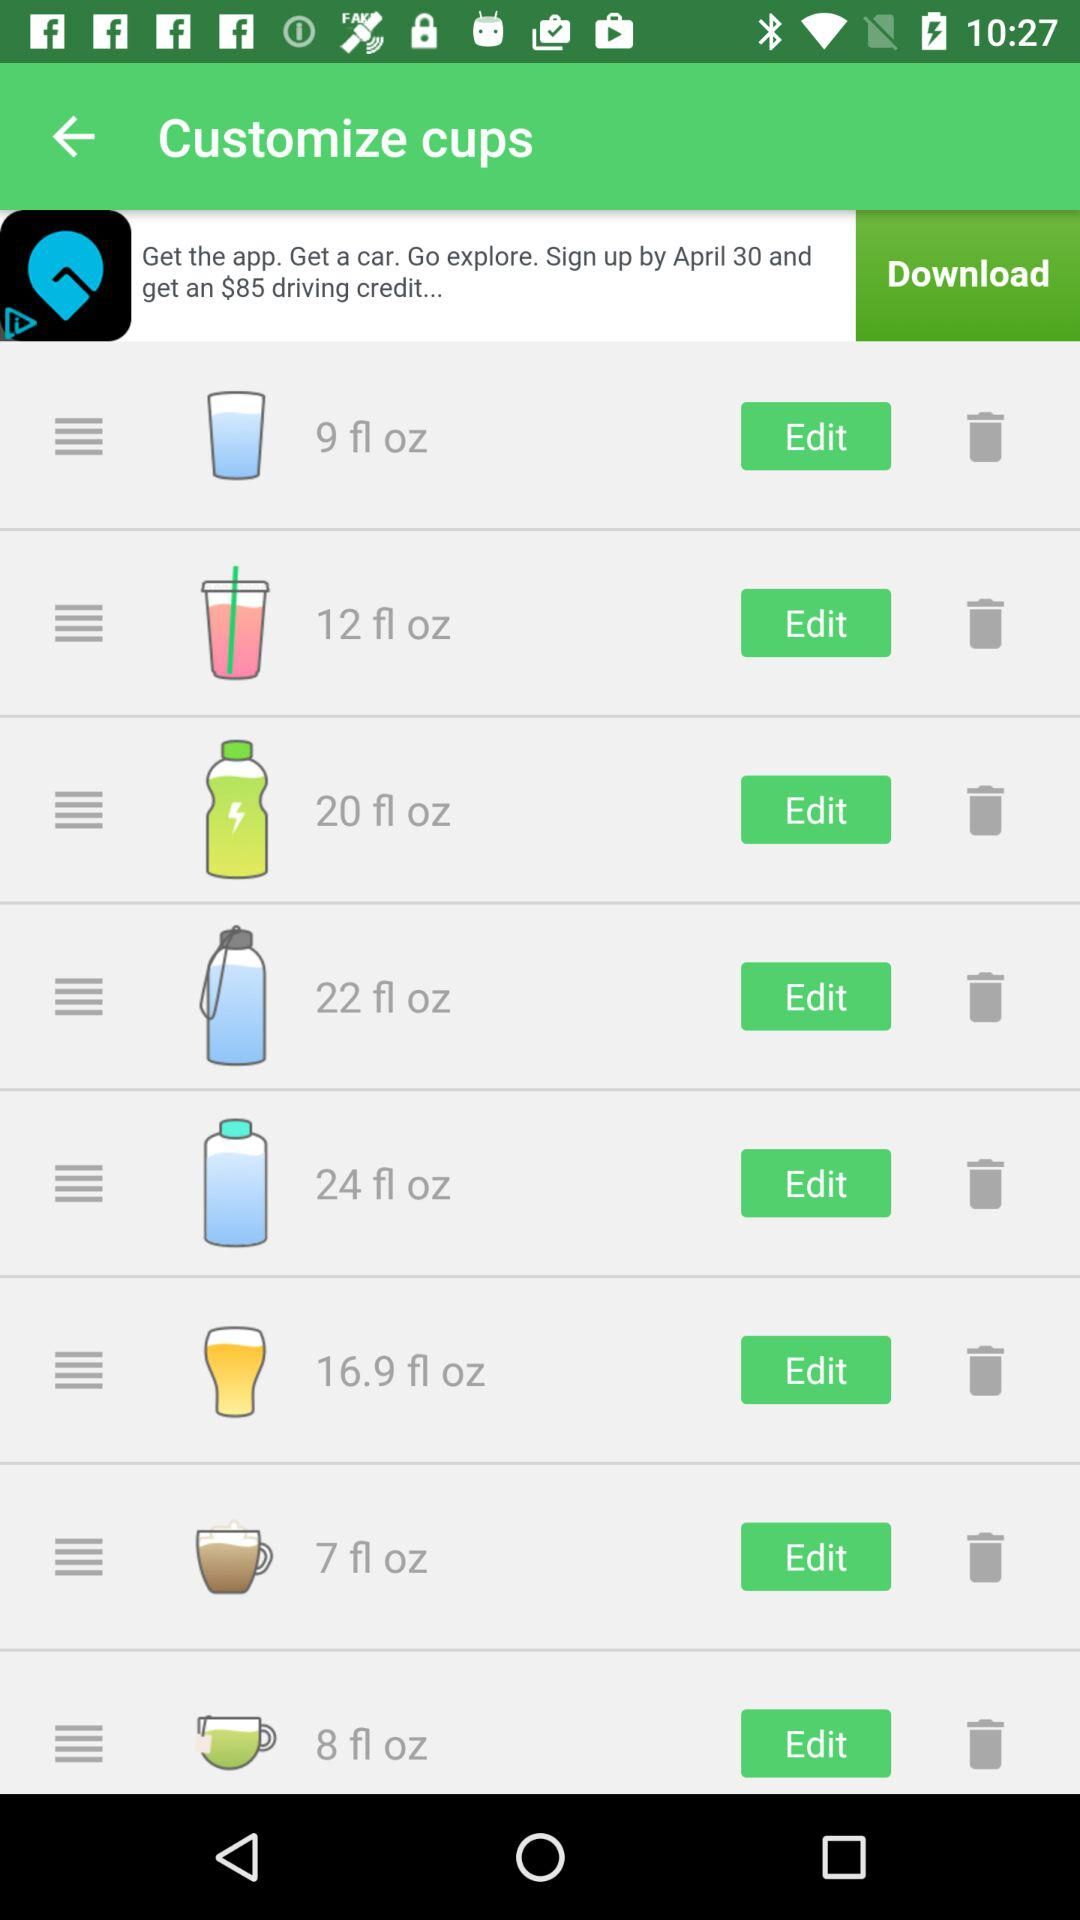How many ounces are there in the largest cup size?
Answer the question using a single word or phrase. 24 fl oz 